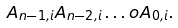<formula> <loc_0><loc_0><loc_500><loc_500>A _ { n - 1 , i } A _ { n - 2 , i } \dots o A _ { 0 , i } .</formula> 